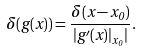Convert formula to latex. <formula><loc_0><loc_0><loc_500><loc_500>\delta ( g ( x ) ) = \frac { \delta ( x - x _ { 0 } ) } { | g ^ { \prime } ( x ) | _ { x _ { 0 } } | } .</formula> 